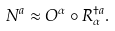Convert formula to latex. <formula><loc_0><loc_0><loc_500><loc_500>N ^ { a } \approx O ^ { \alpha } \circ R ^ { \dagger a } _ { \alpha } .</formula> 